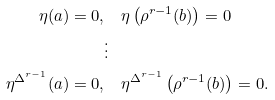Convert formula to latex. <formula><loc_0><loc_0><loc_500><loc_500>\eta ( a ) = 0 , & \quad \eta \left ( \rho ^ { r - 1 } ( b ) \right ) = 0 \\ & \vdots \\ \eta ^ { \Delta ^ { r - 1 } } ( a ) = 0 , & \quad \eta ^ { \Delta ^ { r - 1 } } \left ( \rho ^ { r - 1 } ( b ) \right ) = 0 .</formula> 